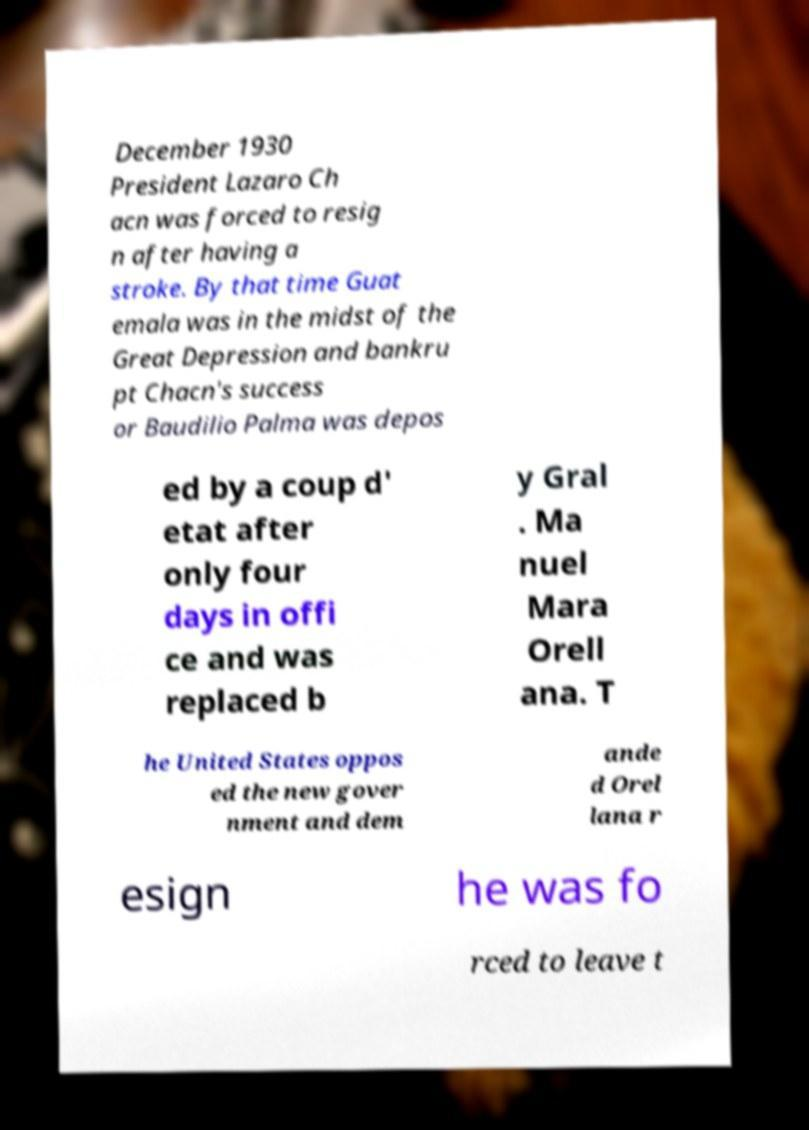Could you assist in decoding the text presented in this image and type it out clearly? December 1930 President Lazaro Ch acn was forced to resig n after having a stroke. By that time Guat emala was in the midst of the Great Depression and bankru pt Chacn's success or Baudilio Palma was depos ed by a coup d' etat after only four days in offi ce and was replaced b y Gral . Ma nuel Mara Orell ana. T he United States oppos ed the new gover nment and dem ande d Orel lana r esign he was fo rced to leave t 